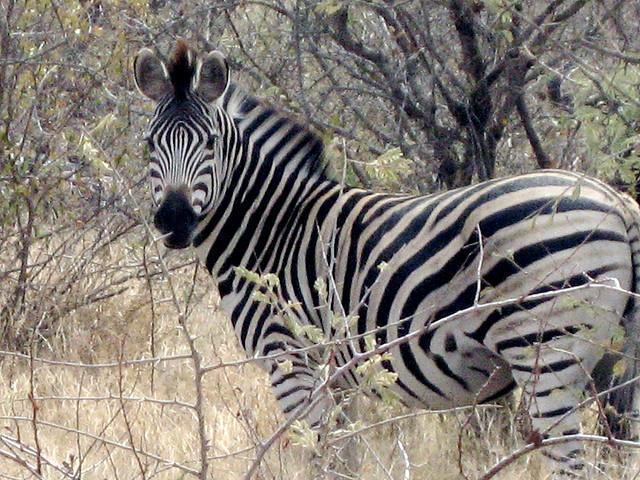How many animals are pictured?
Give a very brief answer. 1. 